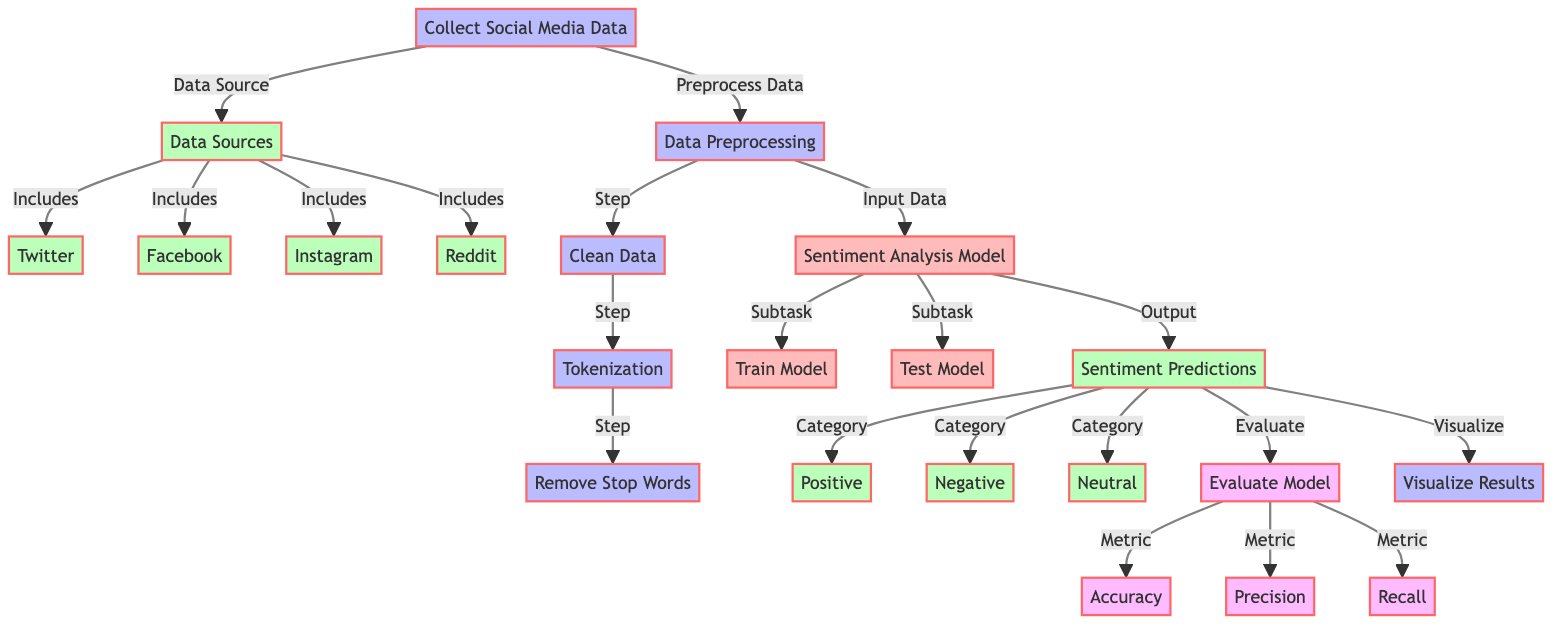What is the first step in the diagram? The diagram starts with the "Collect Social Media Data" process as the first step indicating that data collection is the initial phase.
Answer: Collect Social Media Data How many social media platforms are listed as data sources? The diagram shows four distinct social media platforms: Twitter, Facebook, Instagram, and Reddit. Therefore, there are four data sources.
Answer: 4 What is produced as an output of the sentiment analysis model? The output from the sentiment analysis model is "Sentiment Predictions," which indicates what the model predicts based on the input data.
Answer: Sentiment Predictions Which process follows data preprocessing? After the "Data Preprocessing" step, the next process is "Sentiment Analysis Model," which indicates that the preprocessed data is used for building the sentiment model.
Answer: Sentiment Analysis Model What metrics are used to evaluate the model? The metrics to evaluate the model include Accuracy, Precision, and Recall, which are all connected to the "Evaluate Model" node.
Answer: Accuracy, Precision, Recall What type of data does the sentiment predictions output classify? The sentiment predictions classify the data into three categories: Positive, Negative, and Neutral, showing the audience's reactions to the episodes.
Answer: Positive, Negative, Neutral What is a step that occurs before tokenization? Before tokenization, the "Clean Data" process takes place to prepare the data for the next steps in the analysis.
Answer: Clean Data How does the diagram visualize the results? The diagram indicates that there is a process labeled "Visualize Results" at the end to represent the visualization of the model's output.
Answer: Visualize Results 